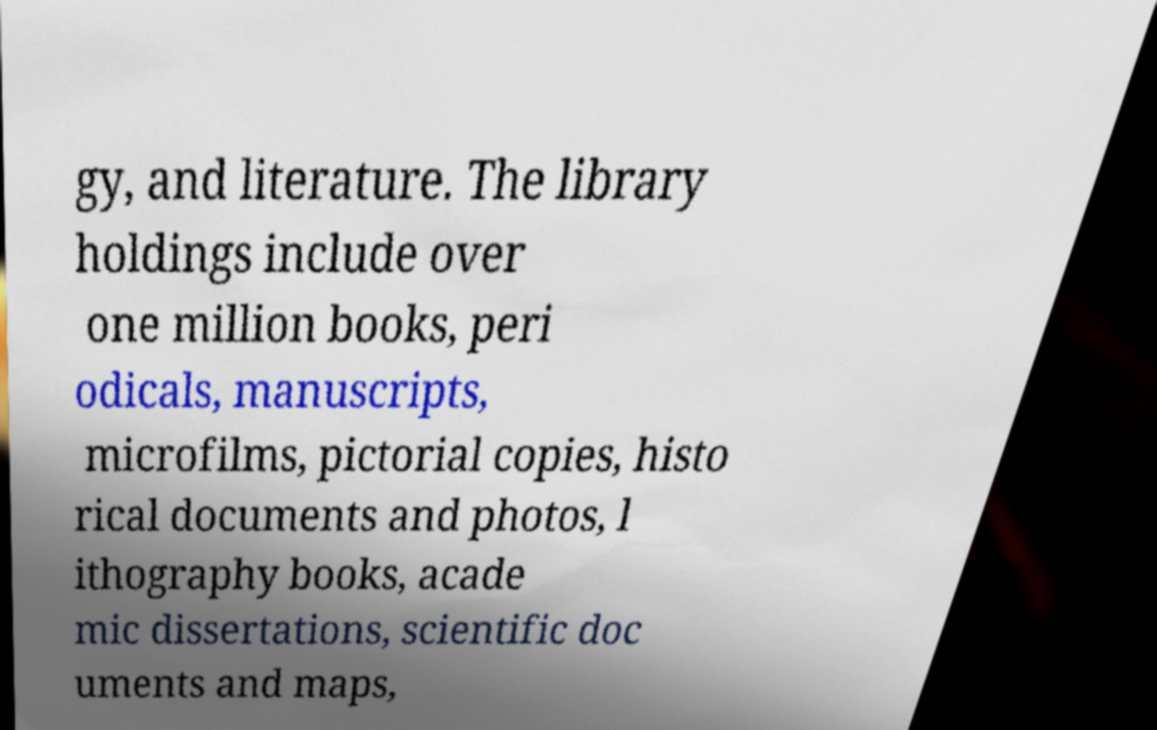What messages or text are displayed in this image? I need them in a readable, typed format. gy, and literature. The library holdings include over one million books, peri odicals, manuscripts, microfilms, pictorial copies, histo rical documents and photos, l ithography books, acade mic dissertations, scientific doc uments and maps, 